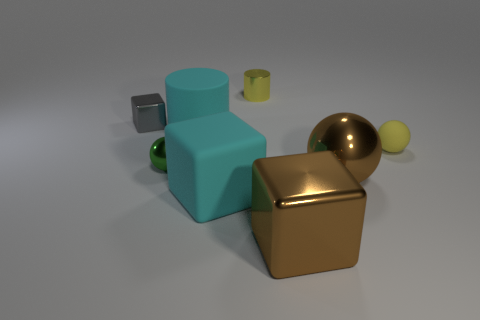Subtract all gray metal cubes. How many cubes are left? 2 Subtract all cubes. How many objects are left? 5 Subtract all yellow balls. How many balls are left? 2 Add 2 cyan balls. How many objects exist? 10 Subtract all cyan cubes. How many blue balls are left? 0 Subtract all small gray shiny blocks. Subtract all gray blocks. How many objects are left? 6 Add 5 gray blocks. How many gray blocks are left? 6 Add 7 big balls. How many big balls exist? 8 Subtract 0 green cylinders. How many objects are left? 8 Subtract 1 cylinders. How many cylinders are left? 1 